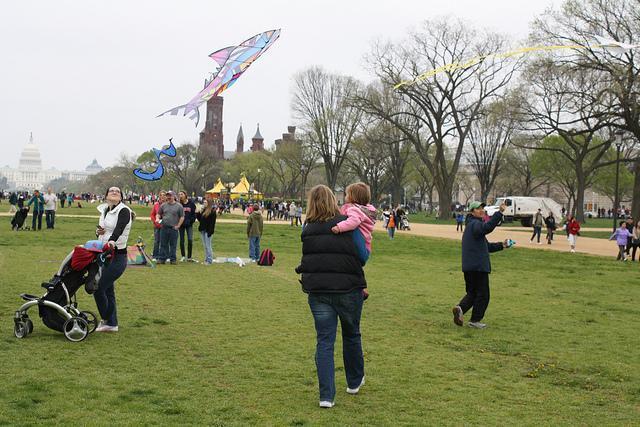How many kites are there?
Give a very brief answer. 2. How many people are there?
Give a very brief answer. 3. 